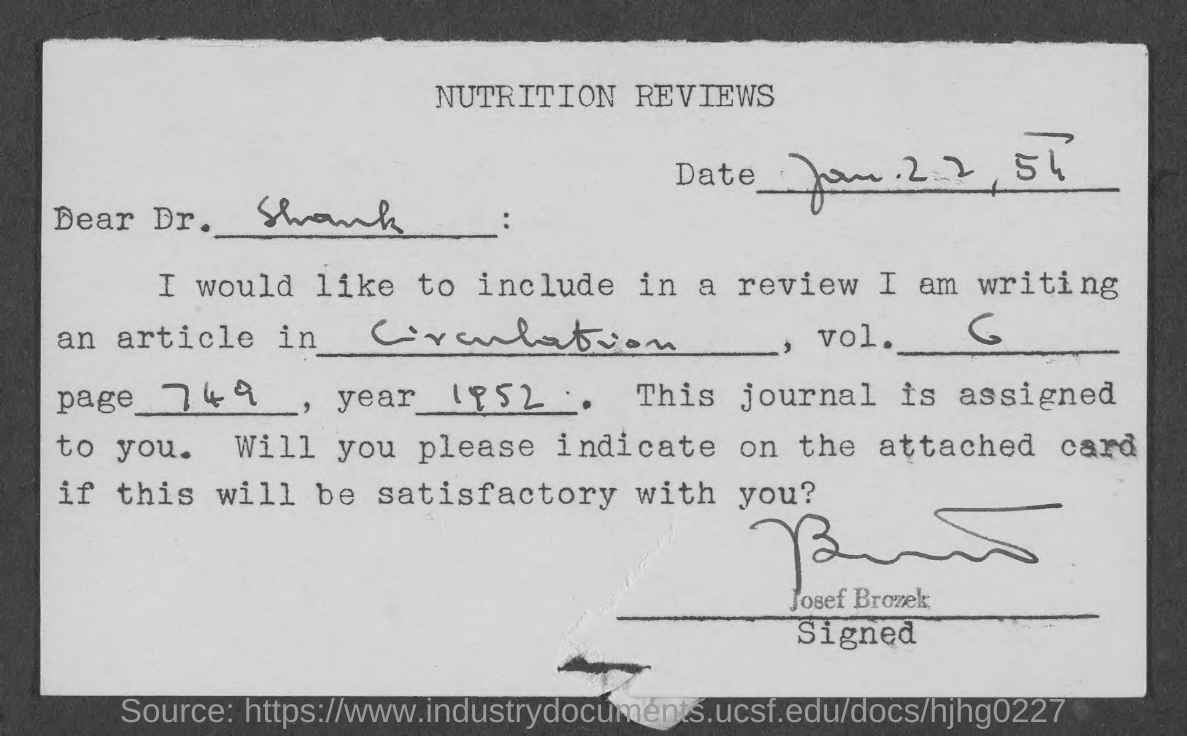Give some essential details in this illustration. The document is about the topic of nutrition, specifically nutrition reviews. The document has been signed by Josef Brozek. The note is addressed to Dr. Shank. 